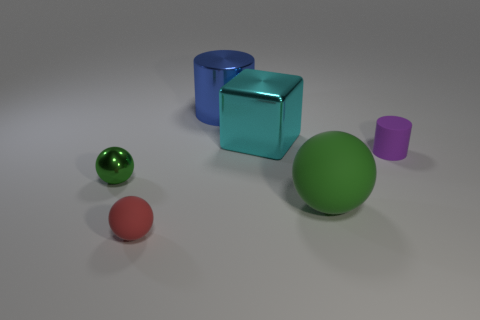Subtract all matte balls. How many balls are left? 1 Subtract all gray cylinders. How many green spheres are left? 2 Add 1 large green matte balls. How many objects exist? 7 Subtract all red spheres. How many spheres are left? 2 Subtract all cyan balls. Subtract all yellow cylinders. How many balls are left? 3 Subtract all cylinders. How many objects are left? 4 Add 5 small red rubber spheres. How many small red rubber spheres are left? 6 Add 2 small brown rubber objects. How many small brown rubber objects exist? 2 Subtract 1 red balls. How many objects are left? 5 Subtract all small purple cylinders. Subtract all rubber cylinders. How many objects are left? 4 